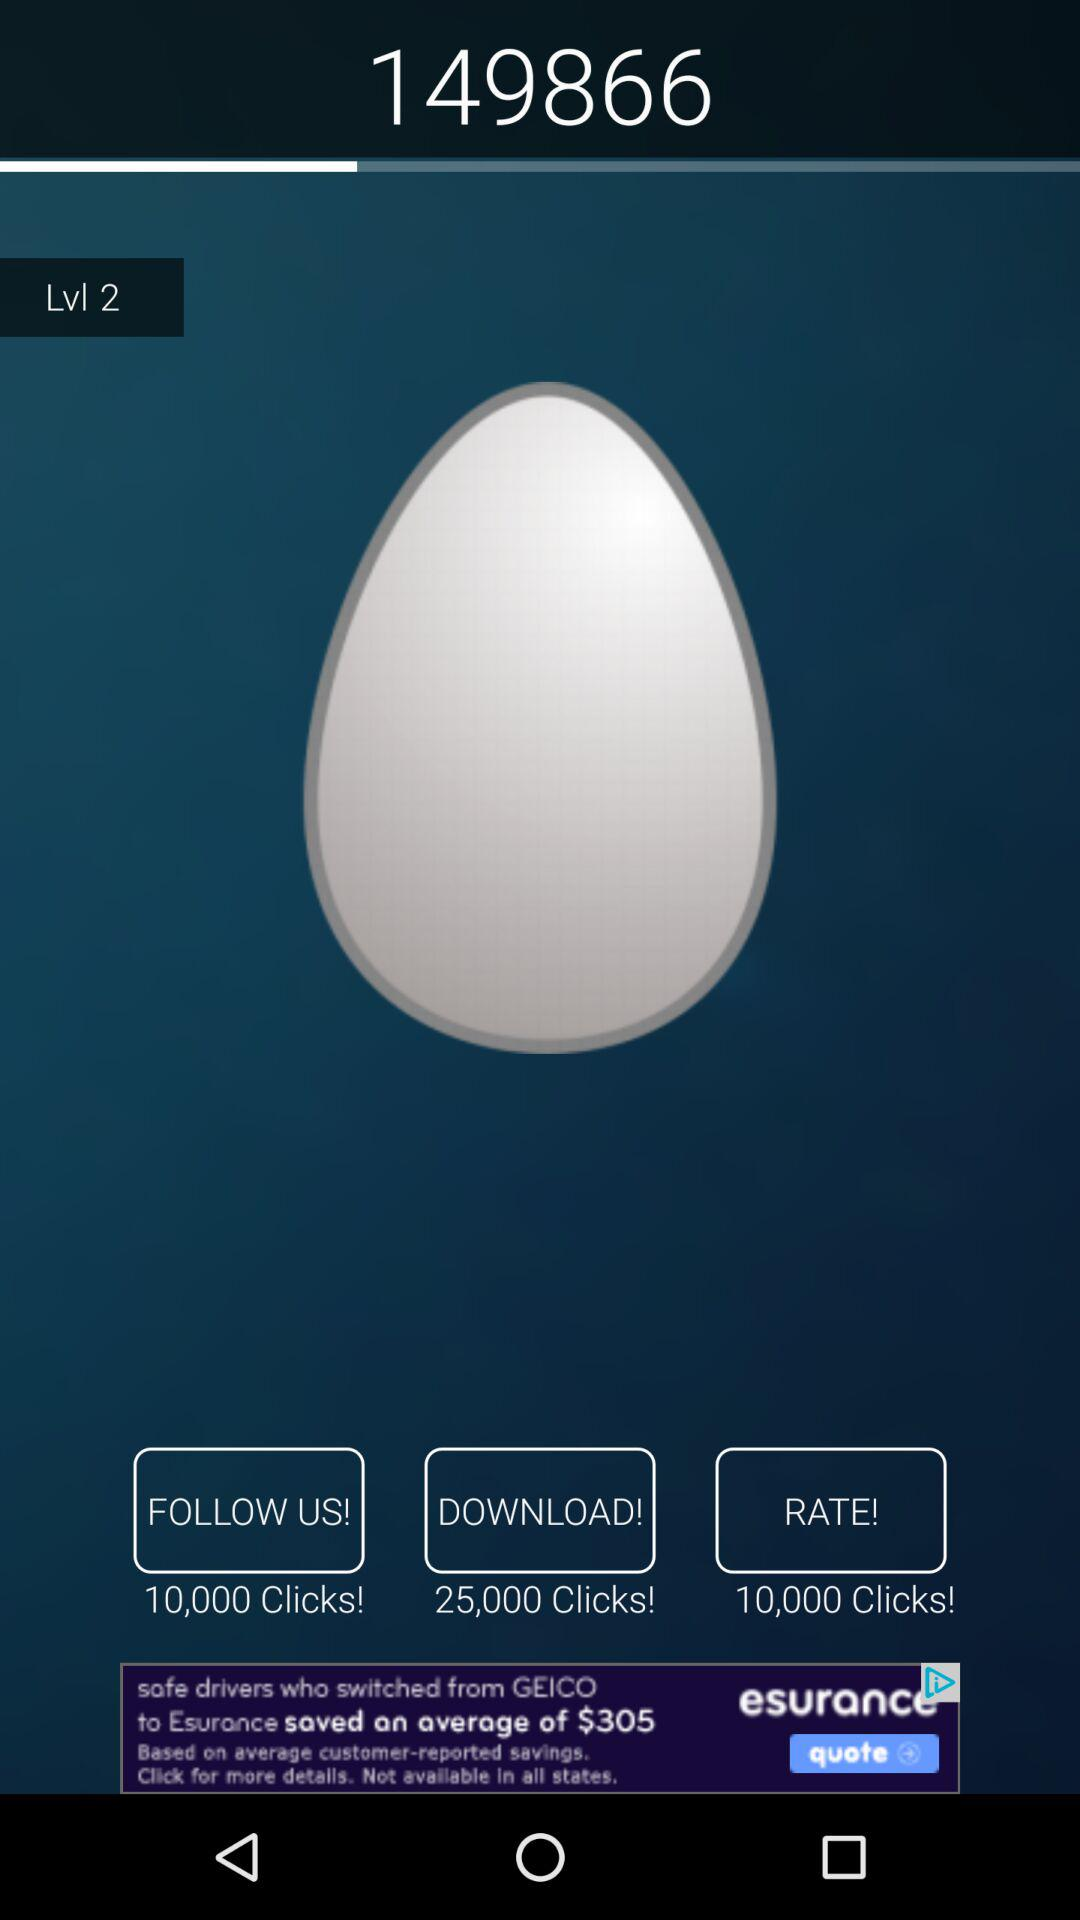What is the level? The level is 2. 